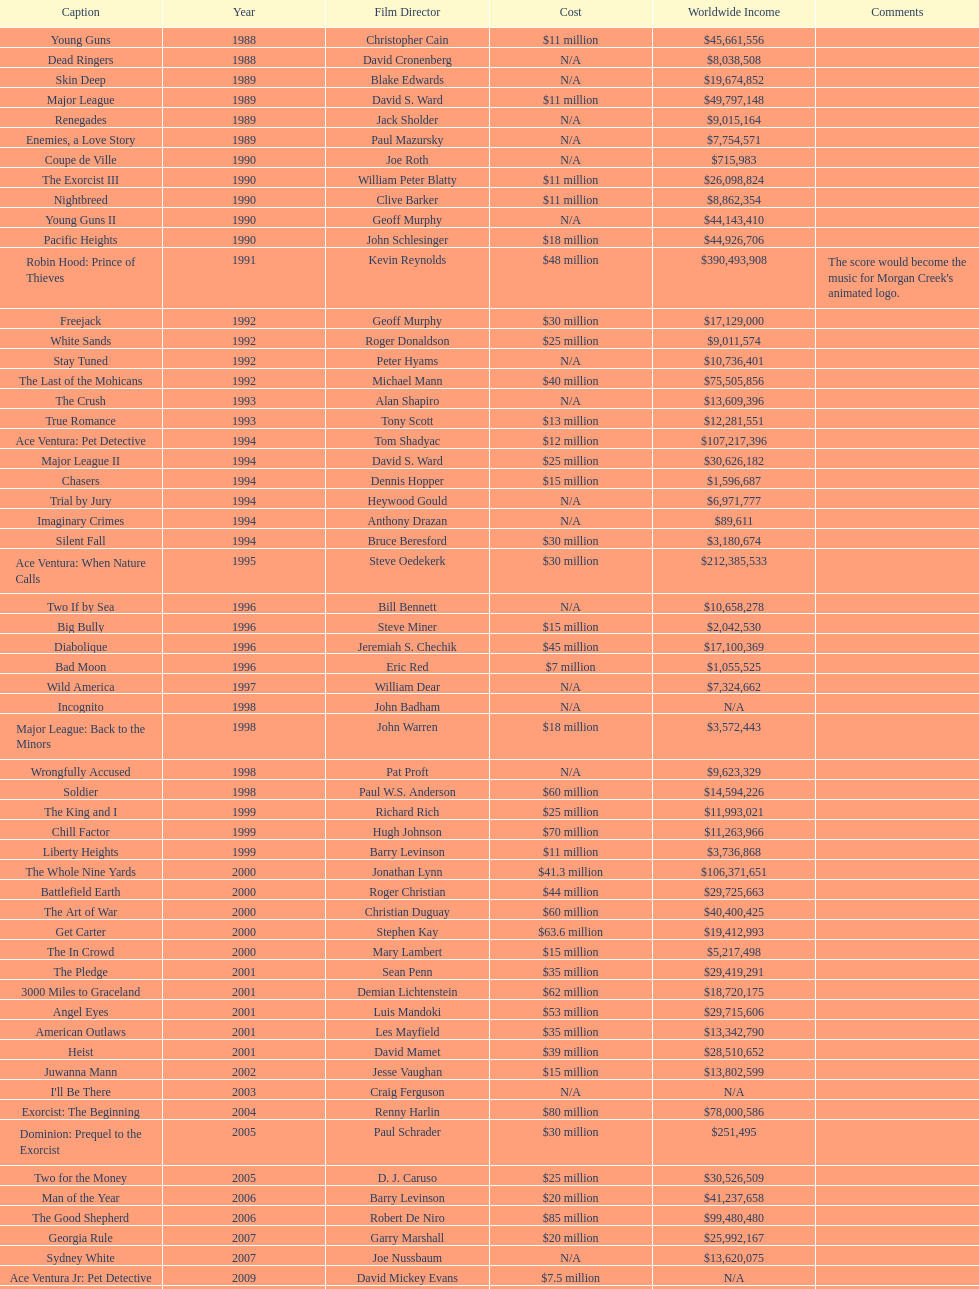Which morgan creek film grossed the most money prior to 1994? Robin Hood: Prince of Thieves. 